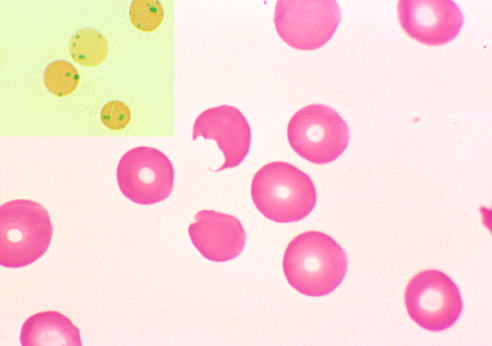re numerous islands of extramedullary hematopoiesis produced?
Answer the question using a single word or phrase. No 